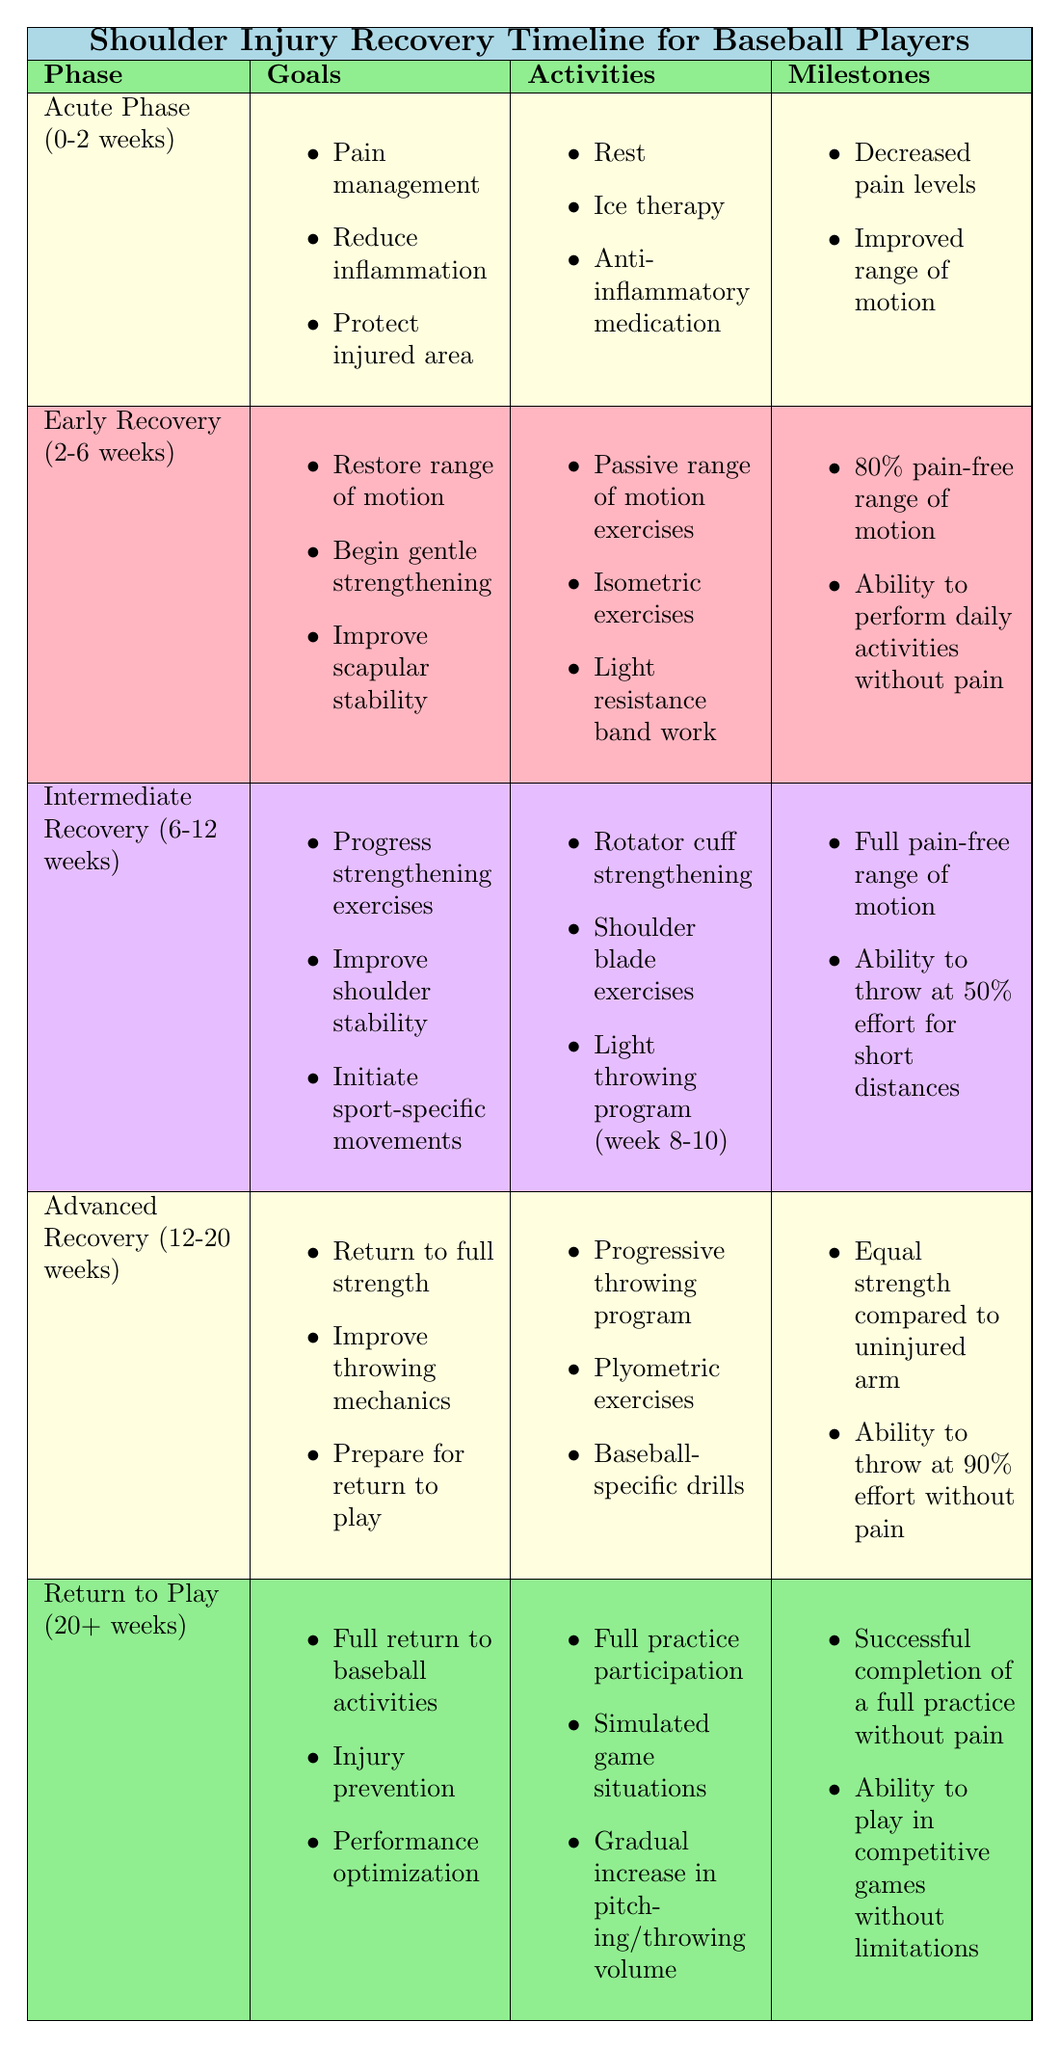What is the primary goal during the Acute Phase? The table indicates that during the Acute Phase (0-2 weeks), the primary goals include pain management, reducing inflammation, and protecting the injured area.
Answer: Pain management, reduce inflammation, protect injured area What activities are included in the Early Recovery phase? According to the table, activities during the Early Recovery phase (2-6 weeks) include passive range of motion exercises, isometric exercises, and light resistance band work.
Answer: Passive range of motion exercises, isometric exercises, light resistance band work Which phase allows throwing at 90% effort without pain? The table states that in the Advanced Recovery phase (12-20 weeks), an individual should be able to throw at 90% effort without pain.
Answer: Advanced Recovery (12-20 weeks) What is the main milestone for the Intermediate Recovery phase? The key milestone for Intermediate Recovery (6-12 weeks) is achieving a full pain-free range of motion and the ability to throw at 50% effort for short distances.
Answer: Full pain-free range of motion, throw at 50% effort How many weeks does the Intermediate Recovery phase last? From the table, the Intermediate Recovery phase lasts from 6 to 12 weeks, which is a total of 6 weeks.
Answer: 6 weeks In which phase is the focus on improving throwing mechanics? Based on the table, the focus on improving throwing mechanics occurs during the Advanced Recovery phase (12-20 weeks).
Answer: Advanced Recovery (12-20 weeks) Which phase requires the ability to perform daily activities without pain as a milestone? The milestone of being able to perform daily activities without pain is linked to the Early Recovery phase (2-6 weeks) in the table.
Answer: Early Recovery (2-6 weeks) Are plyometric exercises included in the activities for the Return to Play phase? Yes, the table confirms that plyometric exercises are one of the activities listed for the Return to Play phase (20+ weeks).
Answer: Yes What differences in recovery might exist based on the type of injury? The table outlines that the type of injury can impact the recovery timeline and specific exercises needed during rehabilitation.
Answer: Yes, it can impact recovery How would a veteran player's recovery timeline differ from that of a young amateur? The information states that age and fitness level may affect healing time and exercise progression, indicating that a veteran player might have a different recovery timeline compared to a young amateur.
Answer: Yes, it would differ 